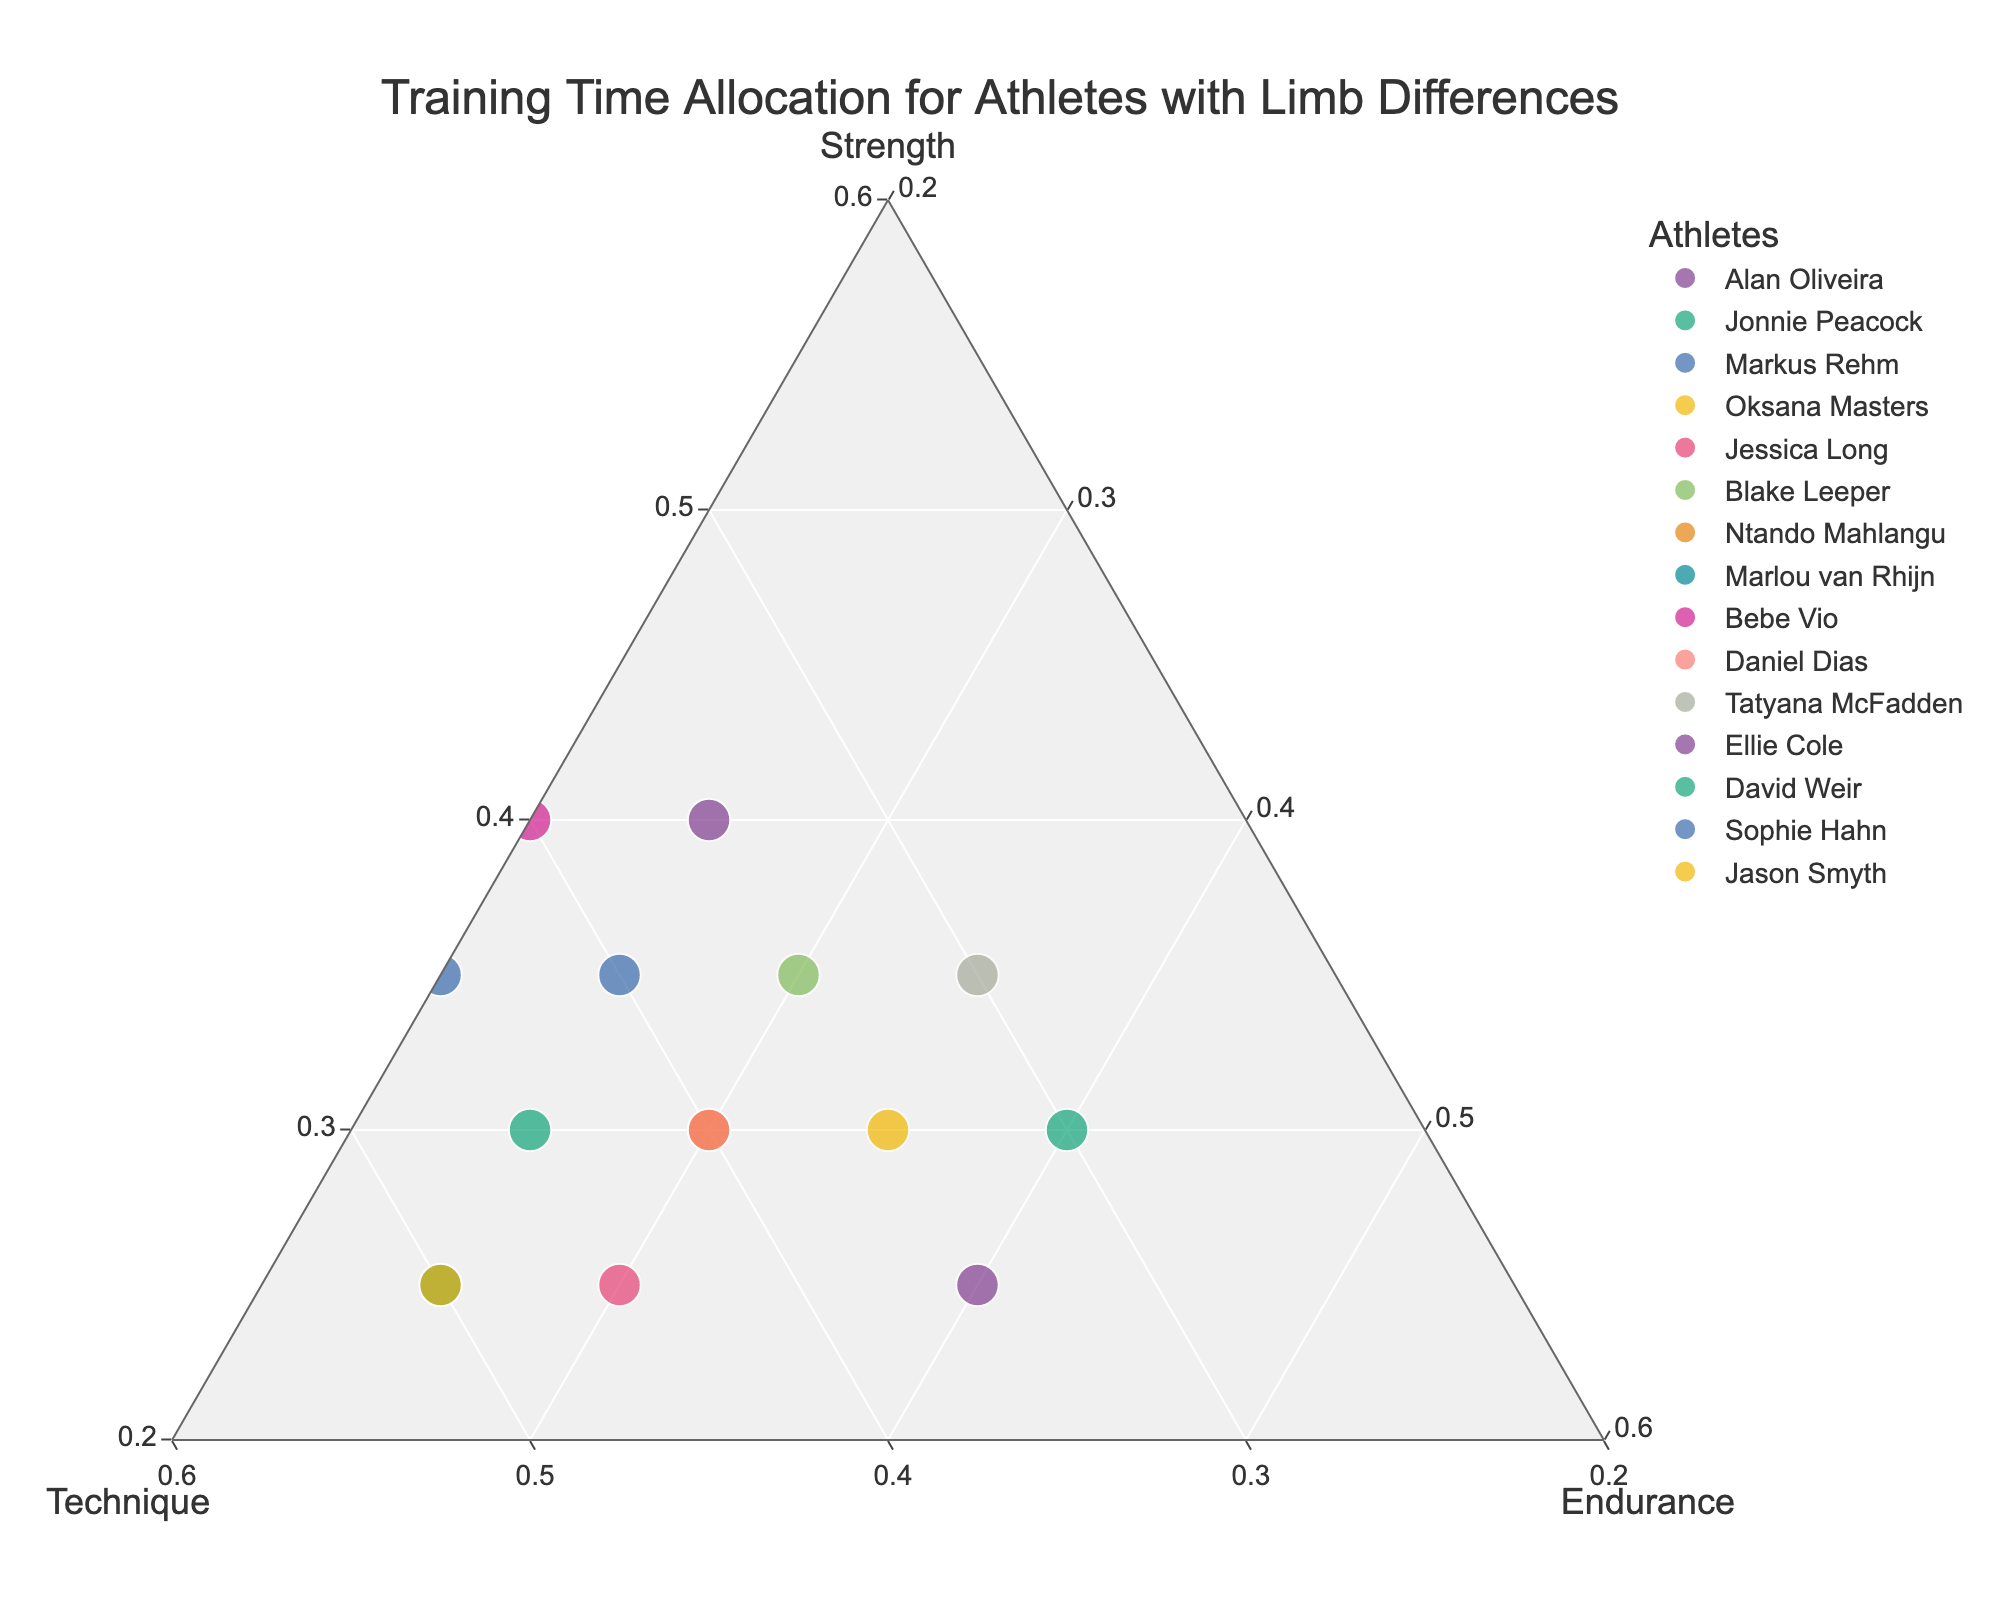What is the title of the plot? The title of the plot is usually found at the top of the figure and provides a brief description of what the plot represents.
Answer: "Training Time Allocation for Athletes with Limb Differences" Which athlete allocates the most time to technique? From the figure, identify the athlete whose data point lies closest to the "Technique" vertex of the ternary plot.
Answer: Jason Smyth How many athletes have a balanced training allocation between strength and endurance? Look for data points that are equidistant from the "Strength" and "Endurance" vertices, forming a line parallel to the "Technique" axis.
Answer: 3 (Oksana Masters, Blake Leeper, and Daniel Dias) Who has the highest training allocation to endurance? Find the data point that lies nearest to the "Endurance" vertex of the ternary plot.
Answer: David Weir What is the average percentage allocation to strength across all athletes? Sum the strength percentages for all athletes and divide by the number of athletes. (40+30+35+30+25+35+30+25+40+30+35+25+30+35+25)/15 = 426/15
Answer: 28.4% Which athlete has the most balanced training distribution (most equidistant to all three vertices)? Look at the data points to see which one is closest to the center of the ternary plot, indicating an equal distribution among strength, technique, and endurance.
Answer: David Weir What is the combined training allocation to strength for Alan Oliveira and Bebe Vio? Add the strength percentages for Alan Oliveira and Bebe Vio. 40 + 40
Answer: 80% Which athlete has the most skewed training distribution towards technique, and by how much more is their technique training compared to their strength training? Identify the athlete farthest from the "Strength" vertex and closest to the "Technique" vertex, then subtract their strength percentage from their technique percentage. Marlou van Rhijn: 50 (Technique) - 25 (Strength)
Answer: Marlou van Rhijn, 25% Between Markus Rehm and Jessica Long, who has a higher aggregate training percentage for strength and technique? Add the strength and technique percentages for both athletes and compare the sums. Markus Rehm: 35+40=75, Jessica Long: 25+45=70
Answer: Markus Rehm Which two athletes have the same training allocation to endurance? Identify data points from the plot where the endurance percentages are equal.
Answer: Alan Oliveira and Jonnie Peacock 